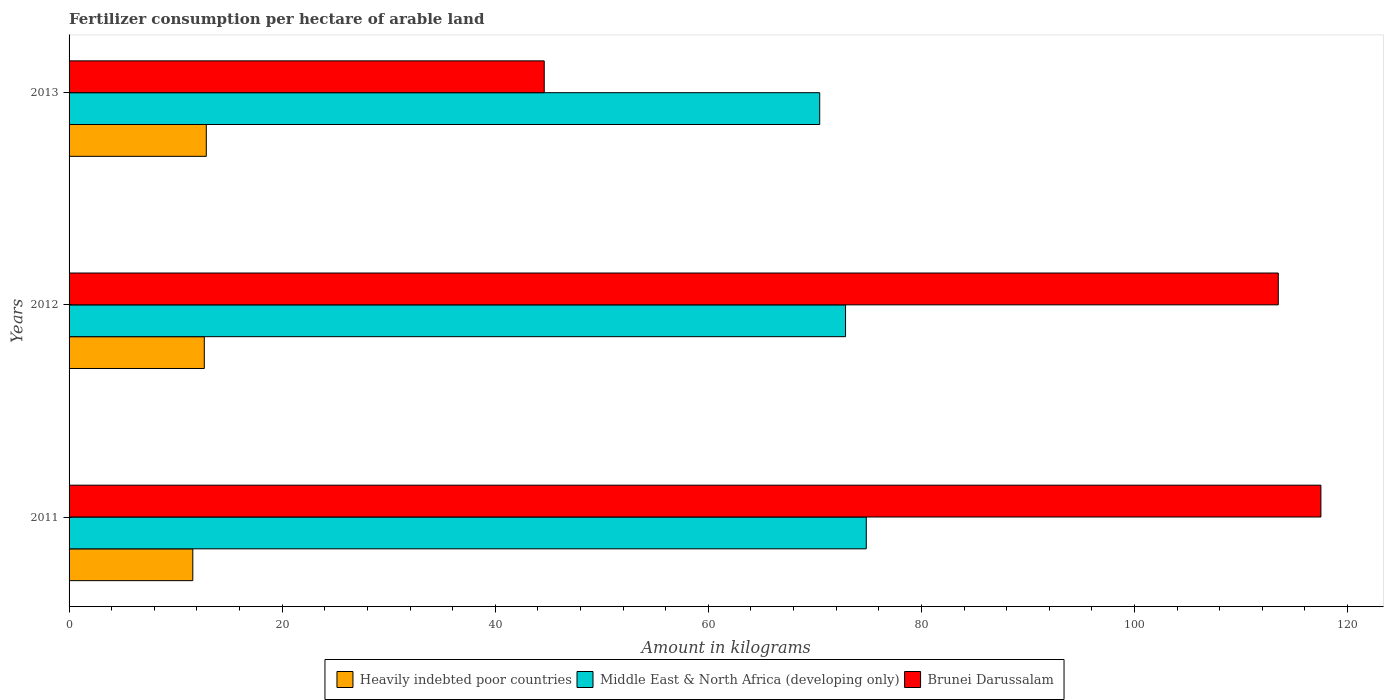How many different coloured bars are there?
Your response must be concise. 3. How many groups of bars are there?
Keep it short and to the point. 3. Are the number of bars per tick equal to the number of legend labels?
Offer a very short reply. Yes. Are the number of bars on each tick of the Y-axis equal?
Offer a very short reply. Yes. How many bars are there on the 2nd tick from the top?
Give a very brief answer. 3. In how many cases, is the number of bars for a given year not equal to the number of legend labels?
Your response must be concise. 0. What is the amount of fertilizer consumption in Middle East & North Africa (developing only) in 2013?
Your answer should be very brief. 70.46. Across all years, what is the maximum amount of fertilizer consumption in Brunei Darussalam?
Keep it short and to the point. 117.5. Across all years, what is the minimum amount of fertilizer consumption in Heavily indebted poor countries?
Ensure brevity in your answer.  11.61. In which year was the amount of fertilizer consumption in Heavily indebted poor countries maximum?
Keep it short and to the point. 2013. What is the total amount of fertilizer consumption in Brunei Darussalam in the graph?
Provide a short and direct response. 275.6. What is the difference between the amount of fertilizer consumption in Middle East & North Africa (developing only) in 2011 and that in 2013?
Provide a succinct answer. 4.37. What is the difference between the amount of fertilizer consumption in Middle East & North Africa (developing only) in 2011 and the amount of fertilizer consumption in Brunei Darussalam in 2013?
Keep it short and to the point. 30.23. What is the average amount of fertilizer consumption in Middle East & North Africa (developing only) per year?
Give a very brief answer. 72.72. In the year 2013, what is the difference between the amount of fertilizer consumption in Heavily indebted poor countries and amount of fertilizer consumption in Brunei Darussalam?
Make the answer very short. -31.72. In how many years, is the amount of fertilizer consumption in Brunei Darussalam greater than 24 kg?
Offer a terse response. 3. What is the ratio of the amount of fertilizer consumption in Heavily indebted poor countries in 2011 to that in 2012?
Provide a succinct answer. 0.92. Is the amount of fertilizer consumption in Brunei Darussalam in 2012 less than that in 2013?
Your answer should be very brief. No. What is the difference between the highest and the lowest amount of fertilizer consumption in Brunei Darussalam?
Your response must be concise. 72.9. In how many years, is the amount of fertilizer consumption in Heavily indebted poor countries greater than the average amount of fertilizer consumption in Heavily indebted poor countries taken over all years?
Make the answer very short. 2. Is the sum of the amount of fertilizer consumption in Brunei Darussalam in 2011 and 2012 greater than the maximum amount of fertilizer consumption in Middle East & North Africa (developing only) across all years?
Offer a very short reply. Yes. What does the 2nd bar from the top in 2013 represents?
Provide a short and direct response. Middle East & North Africa (developing only). What does the 3rd bar from the bottom in 2013 represents?
Provide a succinct answer. Brunei Darussalam. How many bars are there?
Your response must be concise. 9. What is the difference between two consecutive major ticks on the X-axis?
Provide a short and direct response. 20. Are the values on the major ticks of X-axis written in scientific E-notation?
Ensure brevity in your answer.  No. Where does the legend appear in the graph?
Your response must be concise. Bottom center. How many legend labels are there?
Provide a short and direct response. 3. What is the title of the graph?
Your answer should be very brief. Fertilizer consumption per hectare of arable land. Does "Guatemala" appear as one of the legend labels in the graph?
Make the answer very short. No. What is the label or title of the X-axis?
Provide a succinct answer. Amount in kilograms. What is the Amount in kilograms in Heavily indebted poor countries in 2011?
Give a very brief answer. 11.61. What is the Amount in kilograms of Middle East & North Africa (developing only) in 2011?
Provide a succinct answer. 74.83. What is the Amount in kilograms of Brunei Darussalam in 2011?
Offer a terse response. 117.5. What is the Amount in kilograms in Heavily indebted poor countries in 2012?
Your response must be concise. 12.69. What is the Amount in kilograms in Middle East & North Africa (developing only) in 2012?
Provide a succinct answer. 72.88. What is the Amount in kilograms in Brunei Darussalam in 2012?
Provide a succinct answer. 113.5. What is the Amount in kilograms of Heavily indebted poor countries in 2013?
Give a very brief answer. 12.88. What is the Amount in kilograms of Middle East & North Africa (developing only) in 2013?
Offer a terse response. 70.46. What is the Amount in kilograms in Brunei Darussalam in 2013?
Keep it short and to the point. 44.6. Across all years, what is the maximum Amount in kilograms of Heavily indebted poor countries?
Provide a short and direct response. 12.88. Across all years, what is the maximum Amount in kilograms in Middle East & North Africa (developing only)?
Make the answer very short. 74.83. Across all years, what is the maximum Amount in kilograms of Brunei Darussalam?
Your answer should be very brief. 117.5. Across all years, what is the minimum Amount in kilograms of Heavily indebted poor countries?
Offer a very short reply. 11.61. Across all years, what is the minimum Amount in kilograms in Middle East & North Africa (developing only)?
Ensure brevity in your answer.  70.46. Across all years, what is the minimum Amount in kilograms in Brunei Darussalam?
Offer a very short reply. 44.6. What is the total Amount in kilograms in Heavily indebted poor countries in the graph?
Your answer should be compact. 37.19. What is the total Amount in kilograms in Middle East & North Africa (developing only) in the graph?
Ensure brevity in your answer.  218.17. What is the total Amount in kilograms of Brunei Darussalam in the graph?
Offer a very short reply. 275.6. What is the difference between the Amount in kilograms in Heavily indebted poor countries in 2011 and that in 2012?
Ensure brevity in your answer.  -1.08. What is the difference between the Amount in kilograms of Middle East & North Africa (developing only) in 2011 and that in 2012?
Your answer should be very brief. 1.95. What is the difference between the Amount in kilograms of Brunei Darussalam in 2011 and that in 2012?
Keep it short and to the point. 4. What is the difference between the Amount in kilograms in Heavily indebted poor countries in 2011 and that in 2013?
Your answer should be very brief. -1.27. What is the difference between the Amount in kilograms of Middle East & North Africa (developing only) in 2011 and that in 2013?
Ensure brevity in your answer.  4.37. What is the difference between the Amount in kilograms of Brunei Darussalam in 2011 and that in 2013?
Provide a succinct answer. 72.9. What is the difference between the Amount in kilograms in Heavily indebted poor countries in 2012 and that in 2013?
Offer a very short reply. -0.19. What is the difference between the Amount in kilograms in Middle East & North Africa (developing only) in 2012 and that in 2013?
Your answer should be very brief. 2.43. What is the difference between the Amount in kilograms in Brunei Darussalam in 2012 and that in 2013?
Offer a very short reply. 68.9. What is the difference between the Amount in kilograms of Heavily indebted poor countries in 2011 and the Amount in kilograms of Middle East & North Africa (developing only) in 2012?
Offer a terse response. -61.27. What is the difference between the Amount in kilograms of Heavily indebted poor countries in 2011 and the Amount in kilograms of Brunei Darussalam in 2012?
Your answer should be compact. -101.89. What is the difference between the Amount in kilograms of Middle East & North Africa (developing only) in 2011 and the Amount in kilograms of Brunei Darussalam in 2012?
Give a very brief answer. -38.67. What is the difference between the Amount in kilograms of Heavily indebted poor countries in 2011 and the Amount in kilograms of Middle East & North Africa (developing only) in 2013?
Ensure brevity in your answer.  -58.84. What is the difference between the Amount in kilograms in Heavily indebted poor countries in 2011 and the Amount in kilograms in Brunei Darussalam in 2013?
Provide a short and direct response. -32.99. What is the difference between the Amount in kilograms in Middle East & North Africa (developing only) in 2011 and the Amount in kilograms in Brunei Darussalam in 2013?
Ensure brevity in your answer.  30.23. What is the difference between the Amount in kilograms in Heavily indebted poor countries in 2012 and the Amount in kilograms in Middle East & North Africa (developing only) in 2013?
Keep it short and to the point. -57.76. What is the difference between the Amount in kilograms of Heavily indebted poor countries in 2012 and the Amount in kilograms of Brunei Darussalam in 2013?
Give a very brief answer. -31.91. What is the difference between the Amount in kilograms in Middle East & North Africa (developing only) in 2012 and the Amount in kilograms in Brunei Darussalam in 2013?
Your response must be concise. 28.28. What is the average Amount in kilograms of Heavily indebted poor countries per year?
Give a very brief answer. 12.4. What is the average Amount in kilograms of Middle East & North Africa (developing only) per year?
Your answer should be compact. 72.72. What is the average Amount in kilograms of Brunei Darussalam per year?
Offer a very short reply. 91.87. In the year 2011, what is the difference between the Amount in kilograms of Heavily indebted poor countries and Amount in kilograms of Middle East & North Africa (developing only)?
Your response must be concise. -63.21. In the year 2011, what is the difference between the Amount in kilograms of Heavily indebted poor countries and Amount in kilograms of Brunei Darussalam?
Offer a terse response. -105.89. In the year 2011, what is the difference between the Amount in kilograms in Middle East & North Africa (developing only) and Amount in kilograms in Brunei Darussalam?
Ensure brevity in your answer.  -42.67. In the year 2012, what is the difference between the Amount in kilograms in Heavily indebted poor countries and Amount in kilograms in Middle East & North Africa (developing only)?
Your answer should be very brief. -60.19. In the year 2012, what is the difference between the Amount in kilograms of Heavily indebted poor countries and Amount in kilograms of Brunei Darussalam?
Your response must be concise. -100.81. In the year 2012, what is the difference between the Amount in kilograms in Middle East & North Africa (developing only) and Amount in kilograms in Brunei Darussalam?
Your answer should be very brief. -40.62. In the year 2013, what is the difference between the Amount in kilograms of Heavily indebted poor countries and Amount in kilograms of Middle East & North Africa (developing only)?
Your answer should be very brief. -57.58. In the year 2013, what is the difference between the Amount in kilograms of Heavily indebted poor countries and Amount in kilograms of Brunei Darussalam?
Your response must be concise. -31.72. In the year 2013, what is the difference between the Amount in kilograms of Middle East & North Africa (developing only) and Amount in kilograms of Brunei Darussalam?
Offer a very short reply. 25.86. What is the ratio of the Amount in kilograms in Heavily indebted poor countries in 2011 to that in 2012?
Provide a short and direct response. 0.92. What is the ratio of the Amount in kilograms in Middle East & North Africa (developing only) in 2011 to that in 2012?
Keep it short and to the point. 1.03. What is the ratio of the Amount in kilograms of Brunei Darussalam in 2011 to that in 2012?
Offer a terse response. 1.04. What is the ratio of the Amount in kilograms of Heavily indebted poor countries in 2011 to that in 2013?
Give a very brief answer. 0.9. What is the ratio of the Amount in kilograms in Middle East & North Africa (developing only) in 2011 to that in 2013?
Your answer should be very brief. 1.06. What is the ratio of the Amount in kilograms of Brunei Darussalam in 2011 to that in 2013?
Your answer should be compact. 2.63. What is the ratio of the Amount in kilograms in Heavily indebted poor countries in 2012 to that in 2013?
Offer a terse response. 0.99. What is the ratio of the Amount in kilograms in Middle East & North Africa (developing only) in 2012 to that in 2013?
Offer a very short reply. 1.03. What is the ratio of the Amount in kilograms of Brunei Darussalam in 2012 to that in 2013?
Ensure brevity in your answer.  2.54. What is the difference between the highest and the second highest Amount in kilograms in Heavily indebted poor countries?
Offer a terse response. 0.19. What is the difference between the highest and the second highest Amount in kilograms of Middle East & North Africa (developing only)?
Make the answer very short. 1.95. What is the difference between the highest and the lowest Amount in kilograms of Heavily indebted poor countries?
Make the answer very short. 1.27. What is the difference between the highest and the lowest Amount in kilograms of Middle East & North Africa (developing only)?
Offer a terse response. 4.37. What is the difference between the highest and the lowest Amount in kilograms of Brunei Darussalam?
Your answer should be compact. 72.9. 